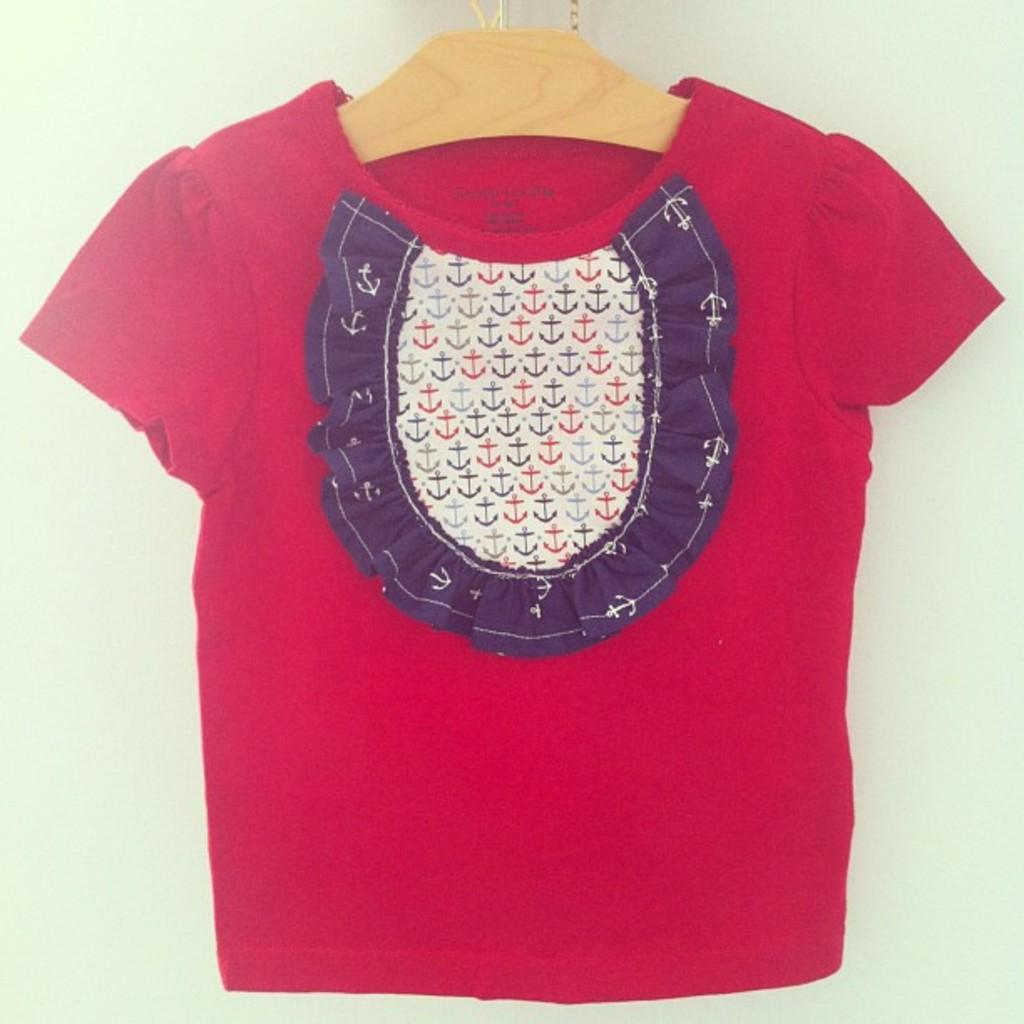What color is the cloth in the image? The cloth in the image is red. What is the cloth hanging on? The red cloth is on a cream color hanger. What type of haircut is the person getting in the image? There is no person getting a haircut in the image; it only features a red cloth on a cream color hanger. What nail size is being used to assemble the furniture in the image? There is no furniture or nails present in the image; it only features a red cloth on a cream color hanger. 